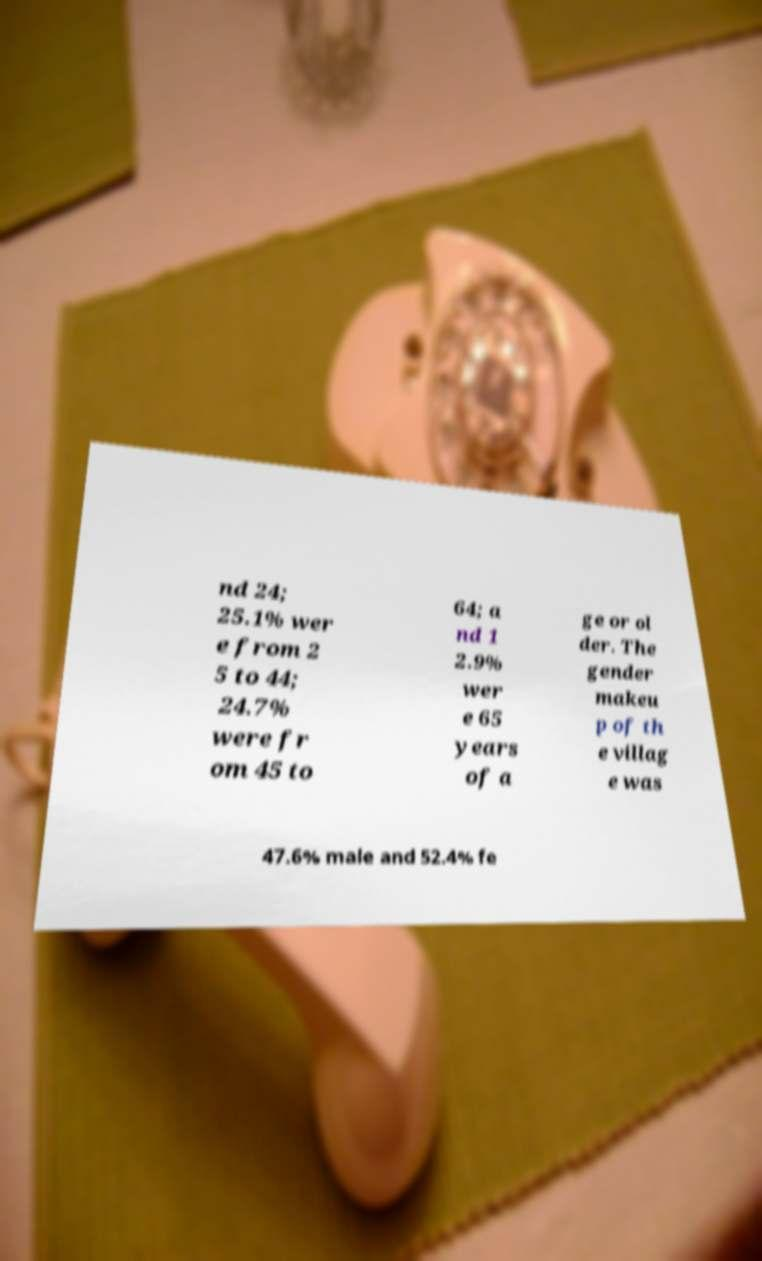Can you accurately transcribe the text from the provided image for me? nd 24; 25.1% wer e from 2 5 to 44; 24.7% were fr om 45 to 64; a nd 1 2.9% wer e 65 years of a ge or ol der. The gender makeu p of th e villag e was 47.6% male and 52.4% fe 